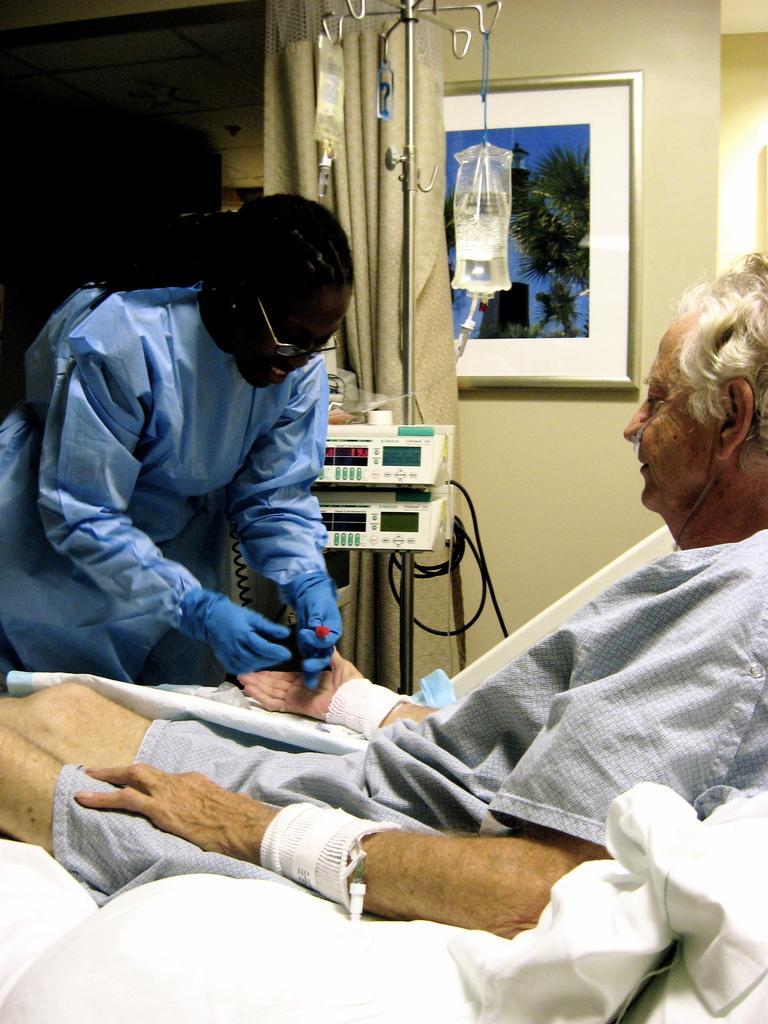Could you give a brief overview of what you see in this image? In this image, there are a few people. Among them, we can see a person standing and the other person is lying on the white colored object. We can see the wall with a photo frame. We can see the curtain and a stand with some objects. We can see some devices. 